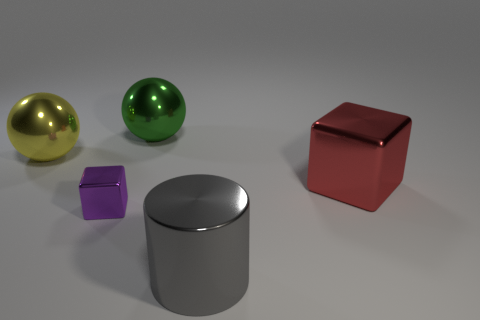Add 4 red metal cubes. How many objects exist? 9 Subtract all cubes. How many objects are left? 3 Subtract 0 gray cubes. How many objects are left? 5 Subtract all green metal balls. Subtract all gray cylinders. How many objects are left? 3 Add 2 purple cubes. How many purple cubes are left? 3 Add 5 small gray rubber things. How many small gray rubber things exist? 5 